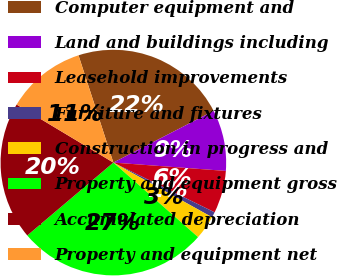Convert chart. <chart><loc_0><loc_0><loc_500><loc_500><pie_chart><fcel>Computer equipment and<fcel>Land and buildings including<fcel>Leasehold improvements<fcel>Furniture and fixtures<fcel>Construction in progress and<fcel>Property and equipment gross<fcel>Accumulated depreciation<fcel>Property and equipment net<nl><fcel>22.43%<fcel>8.75%<fcel>6.09%<fcel>0.78%<fcel>3.44%<fcel>27.33%<fcel>19.78%<fcel>11.4%<nl></chart> 